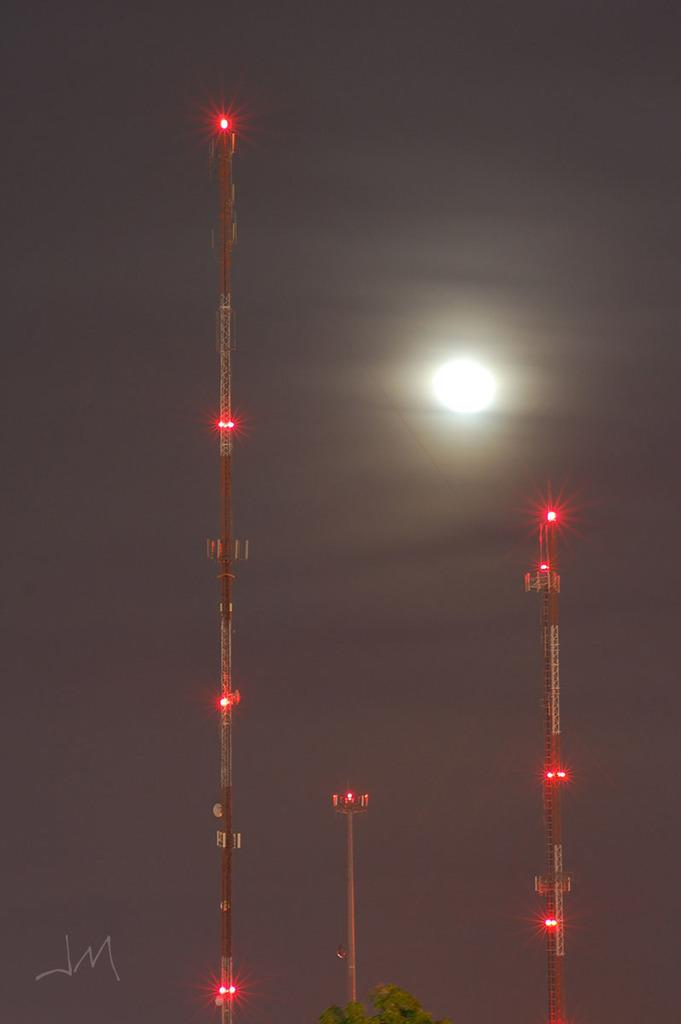What type of natural element can be seen in the image? There is a tree in the image. What structures are present with lights in the image? There are towers with lights in the image. What is visible in the sky in the image? The sky is visible in the image, and the moon is present. What is the color of the background in the image? The background of the image is black. Can you tell me how many people are holding blades in the image? There are no people or blades present in the image. What time is displayed on the clock in the image? There is no clock present in the image. 